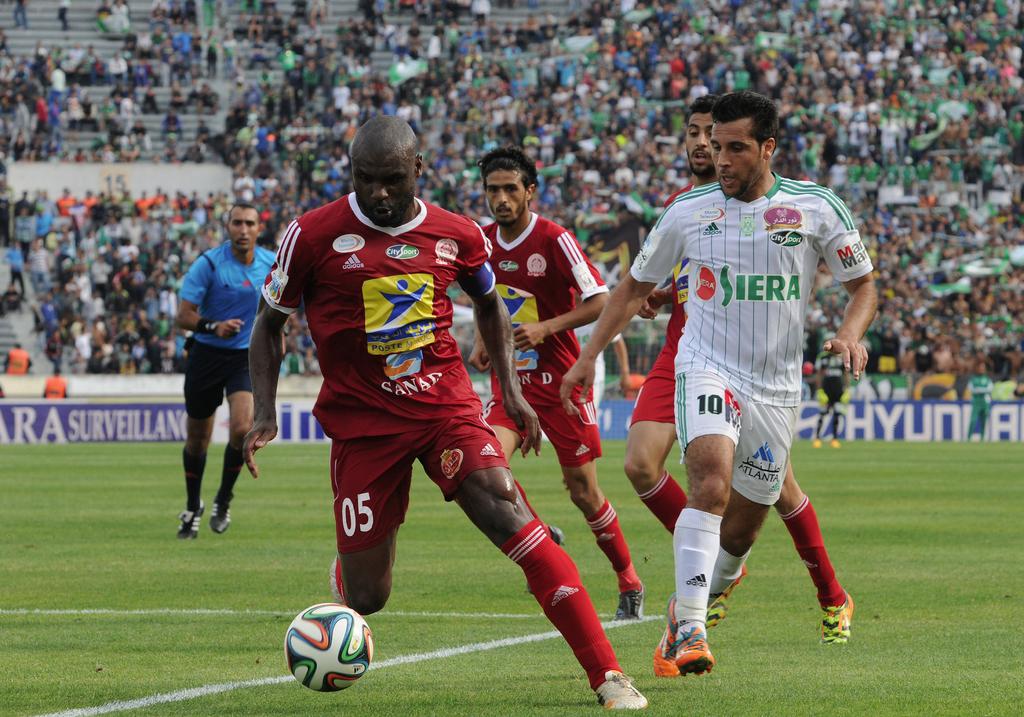What number is the defender?
Your answer should be compact. 10. What number jersey is the red player?
Keep it short and to the point. 05. 